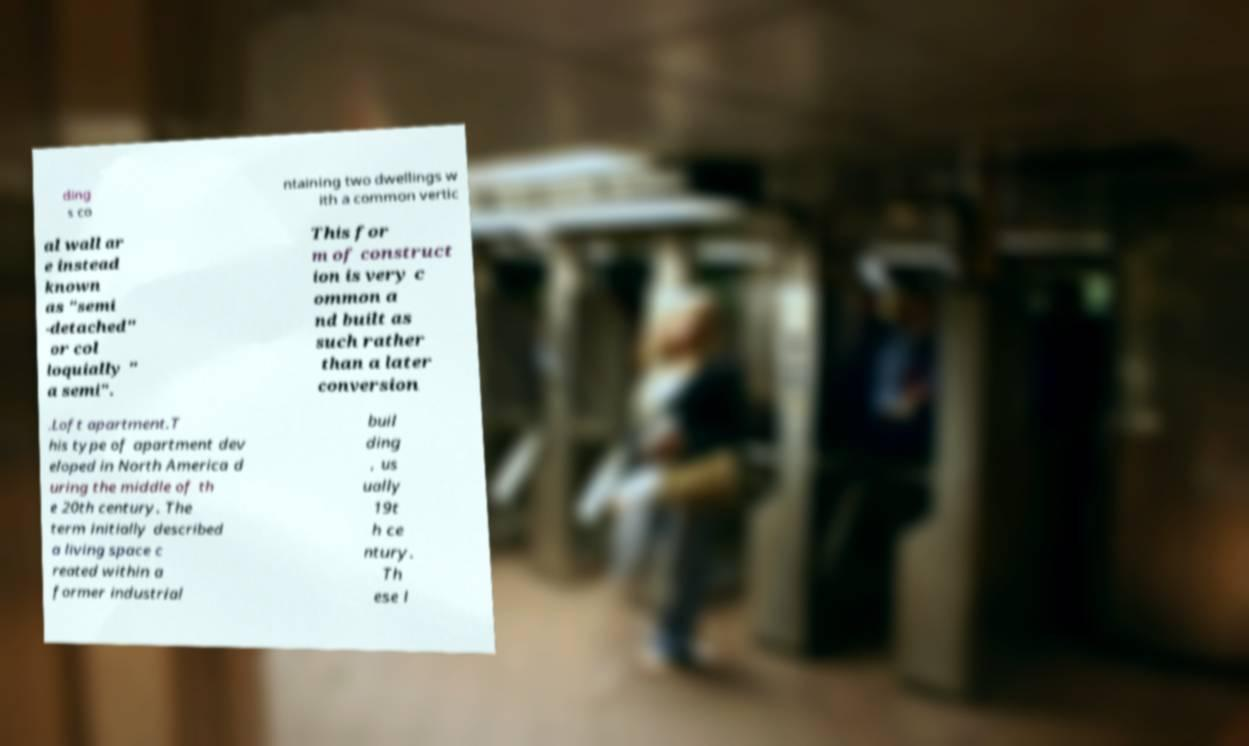Can you accurately transcribe the text from the provided image for me? ding s co ntaining two dwellings w ith a common vertic al wall ar e instead known as "semi -detached" or col loquially " a semi". This for m of construct ion is very c ommon a nd built as such rather than a later conversion .Loft apartment.T his type of apartment dev eloped in North America d uring the middle of th e 20th century. The term initially described a living space c reated within a former industrial buil ding , us ually 19t h ce ntury. Th ese l 